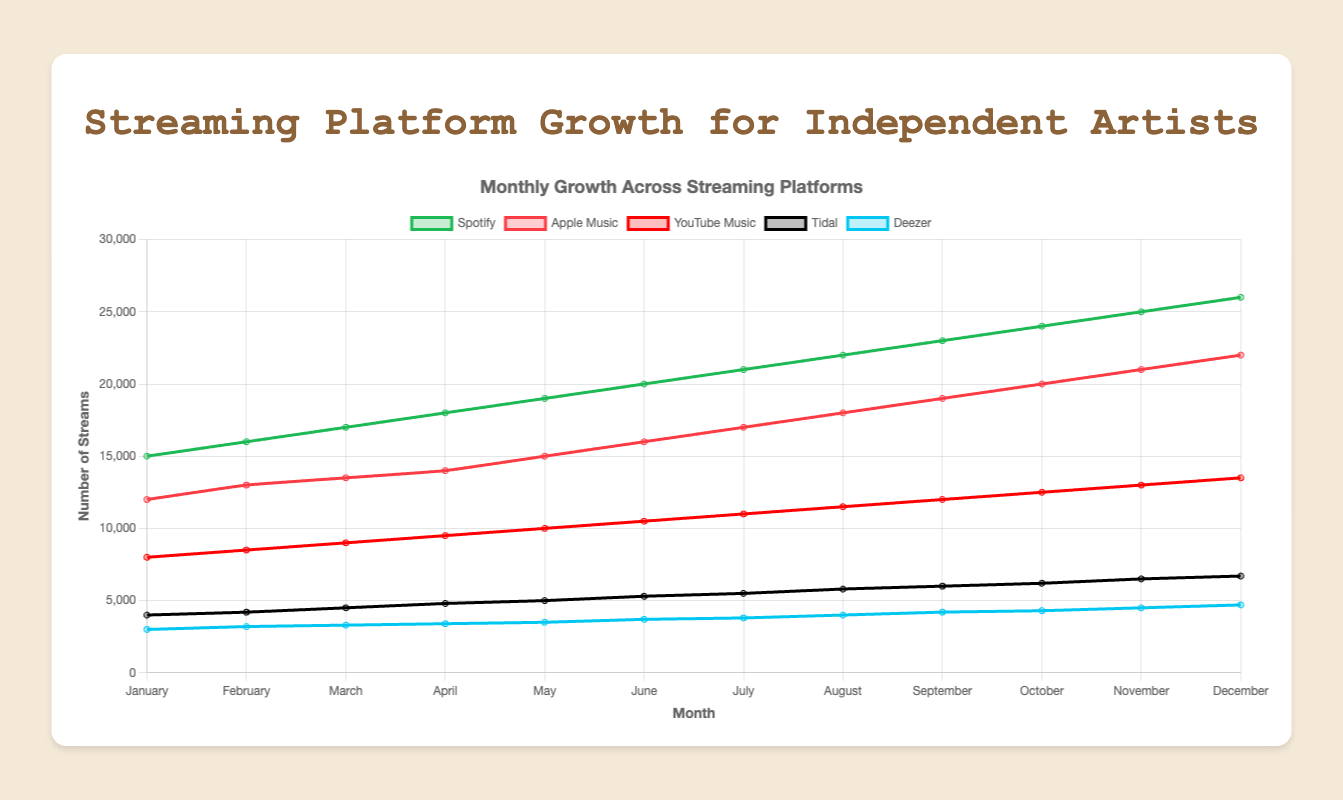What streaming platform had the highest number of streams in December? By observing the chart, locate where December is on the x-axis and then compare the heights of the lines for each platform. Spotify has the highest value in December.
Answer: Spotify How did the number of streams for Apple Music change from January to December? Find January and December on the x-axis and compare the points for Apple Music. In January, it was 12000 streams, and in December, it was 22000 streams. The change is 22000 - 12000 = 10000 streams.
Answer: Increased by 10000 Which platform saw the highest growth rate from January to December? Calculate the growth rate for each platform by subtracting the streams in January from the streams in December and then identify the platform with the highest value. Spotify grew by 26000 - 15000 = 11000, Apple Music by 22000 - 12000 = 10000, YouTube Music by 13500 - 8000 = 5500, Tidal by 6700 - 4000 = 2700, Deezer by 4700 - 3000 = 1700. Spotify had the highest growth rate.
Answer: Spotify What month did YouTube Music surpass 10000 streams? Follow the YouTube Music line until it crosses 10000 on the y-axis. YouTube Music surpasses 10000 streams in July.
Answer: July Which months show an equal number of streams for both Deezer and Tidal? Compare the values for Deezer and Tidal month by month. They have equal streams in August (4000 streams for both).
Answer: August How does the pattern of growth for Tidal compare to that of Spotify throughout the year? Notice that both platforms exhibit consistent growth, with Spotify having a steeper incline, indicating a larger increase month over month compared to Tidal.
Answer: Both grow steadily, but Spotify grows faster What was the average number of streams on Apple Music from January to June? Add the streams from January to June, then divide by the number of months. The sum is 12000 + 13000 + 13500 + 14000 + 15000 + 16000 = 83500, so the average is 83500 / 6 = 13917 streams.
Answer: 13917 By how much did the number of streams on Deezer increase from July to December? Check the value for Deezer in July (3800) and December (4700), then subtract July from December. 4700 - 3800 = 900
Answer: 900 Which platform had the least number of streams overall in any month of the year? Look for the smallest value on the chart across all platforms for any month. Deezer had the least number of streams with 3000 in January.
Answer: Deezer in January How does the stream count for YouTube Music in March compare to Tidal in December? Find the values for YouTube Music in March (9000) and Tidal in December (6700), then compare. YouTube Music in March has more streams than Tidal in December.
Answer: YouTube Music has more 